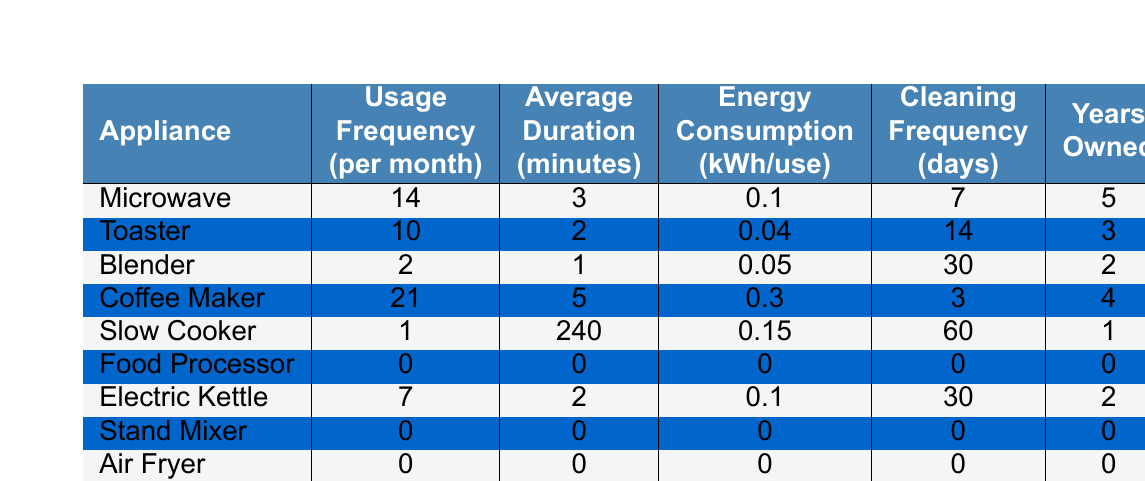What is the usage frequency of the Coffee Maker? The table shows that the Coffee Maker has a usage frequency of 21 per month.
Answer: 21 Which appliance has the highest average duration of use? The Slow Cooker has the highest average duration of 240 minutes.
Answer: Slow Cooker How many appliances are used more than 5 times a month? The Microwave (14), Toaster (10), and Coffee Maker (21) are the only appliances used more than 5 times, totaling 3 appliances.
Answer: 3 Are there any appliances that have never been used? The Food Processor, Stand Mixer, and Air Fryer have a usage frequency of 0, indicating they have never been used.
Answer: Yes What is the total annual usage frequency for all appliances? Summing the monthly usage frequencies gives (14 + 10 + 2 + 21 + 1 + 0 + 7 + 0 + 0 + 3) = 58. Annual usage is 58 * 12 months = 696.
Answer: 696 Which appliance has the lowest energy consumption per use? The Toaster has the lowest energy consumption of 0.04 kWh per use.
Answer: Toaster How does the average duration of the Slow Cooker usage compare to the Coffee Maker? The Slow Cooker has an average duration of 240 minutes, while the Coffee Maker has 5 minutes, showing the Slow Cooker is used much longer on average.
Answer: Slow Cooker is longer What is the average number of cleaning days for all appliances? To find the average cleaning frequency, add up the cleaning days (7 + 14 + 30 + 3 + 60 + 0 + 30 + 0 + 0 + 14) = 158 and divide by 10 appliances, resulting in 15.8 days.
Answer: 15.8 days How many years has the Blender been owned compared to the Electric Kettle? The Blender has been owned for 2 years, while the Electric Kettle has been owned for 2 years as well, so they have been owned for the same length of time.
Answer: Same (2 years) What percentage of appliances are used less than 5 times a month? There are 7 appliances used less than 5 times out of 10 appliances total, which is 70%.
Answer: 70% 